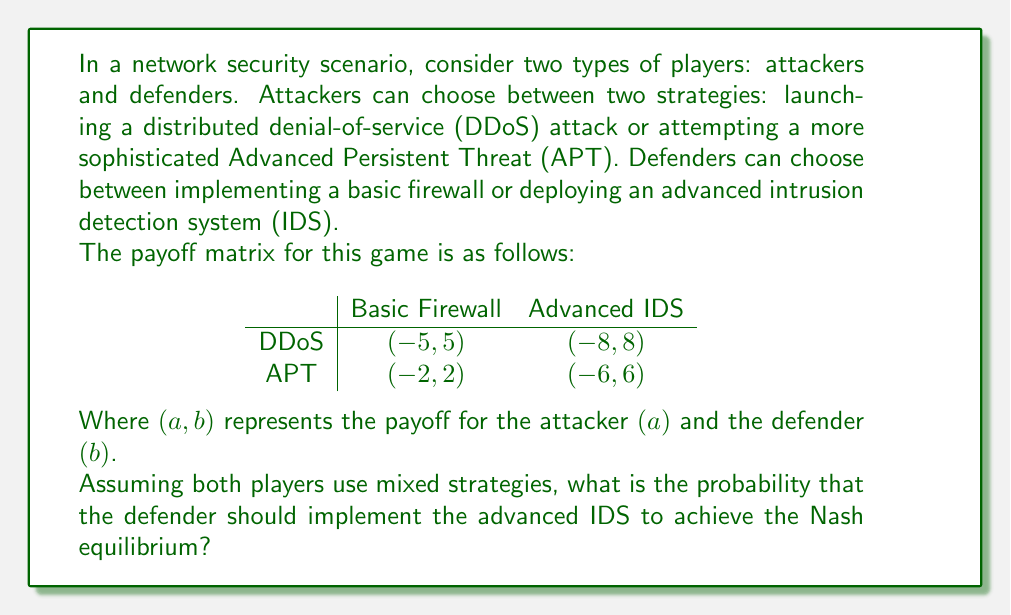Can you solve this math problem? To solve this problem, we need to use the concept of mixed strategy Nash equilibrium in evolutionary game theory. Let's approach this step-by-step:

1) Let $p$ be the probability that the attacker chooses DDoS, and $q$ be the probability that the defender chooses the basic firewall.

2) For the attacker to be indifferent between DDoS and APT, the expected payoffs should be equal:

   $-5q + (-8)(1-q) = -2q + (-6)(1-q)$

3) Simplify the equation:
   
   $-5q - 8 + 8q = -2q - 6 + 6q$
   $3q - 8 = 4q - 6$
   $-q = 2$
   $q = -2$

4) Since $q$ represents a probability, it must be between 0 and 1. The result $q = -2$ is outside this range, which means the defender should always choose the advanced IDS (i.e., $q = 0$).

5) Now, for the defender to be indifferent between basic firewall and advanced IDS, the expected payoffs should be equal:

   $5p + 2(1-p) = 8p + 6(1-p)$

6) Simplify the equation:
   
   $5p + 2 - 2p = 8p + 6 - 6p$
   $3p + 2 = 2p + 6$
   $p = 4/3$

7) Again, since $p$ represents a probability, it must be between 0 and 1. The result $p = 4/3$ is outside this range, which means the attacker should always choose DDoS (i.e., $p = 1$).

8) Therefore, the Nash equilibrium is a pure strategy where the attacker always chooses DDoS and the defender always chooses the advanced IDS.
Answer: The probability that the defender should implement the advanced IDS in the Nash equilibrium is 1 (or 100%). 